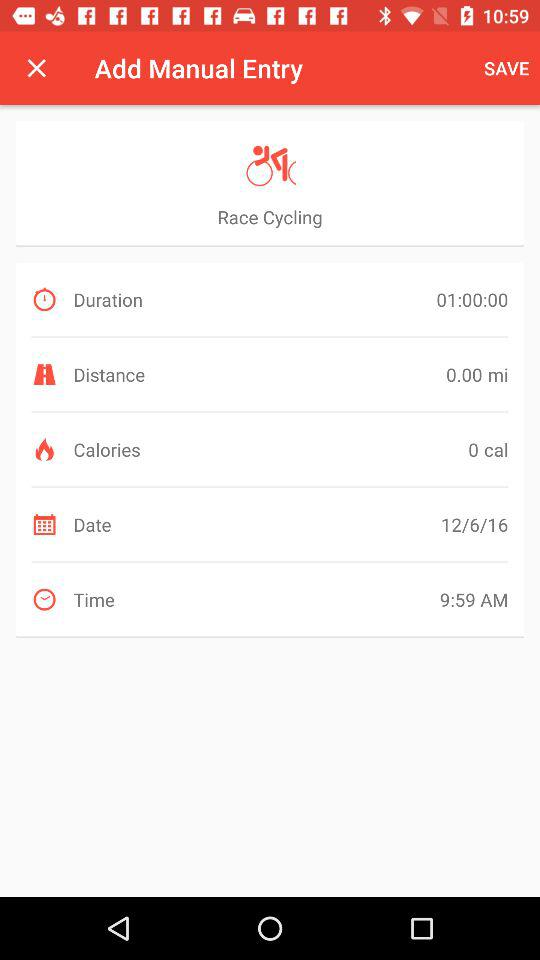How many calories are burned? The number of calories that are burned is 0. 